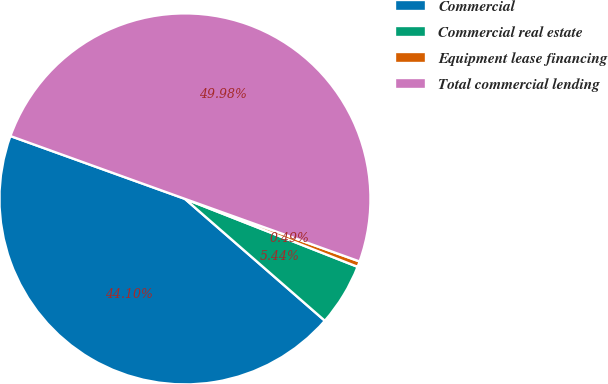<chart> <loc_0><loc_0><loc_500><loc_500><pie_chart><fcel>Commercial<fcel>Commercial real estate<fcel>Equipment lease financing<fcel>Total commercial lending<nl><fcel>44.1%<fcel>5.44%<fcel>0.49%<fcel>49.98%<nl></chart> 